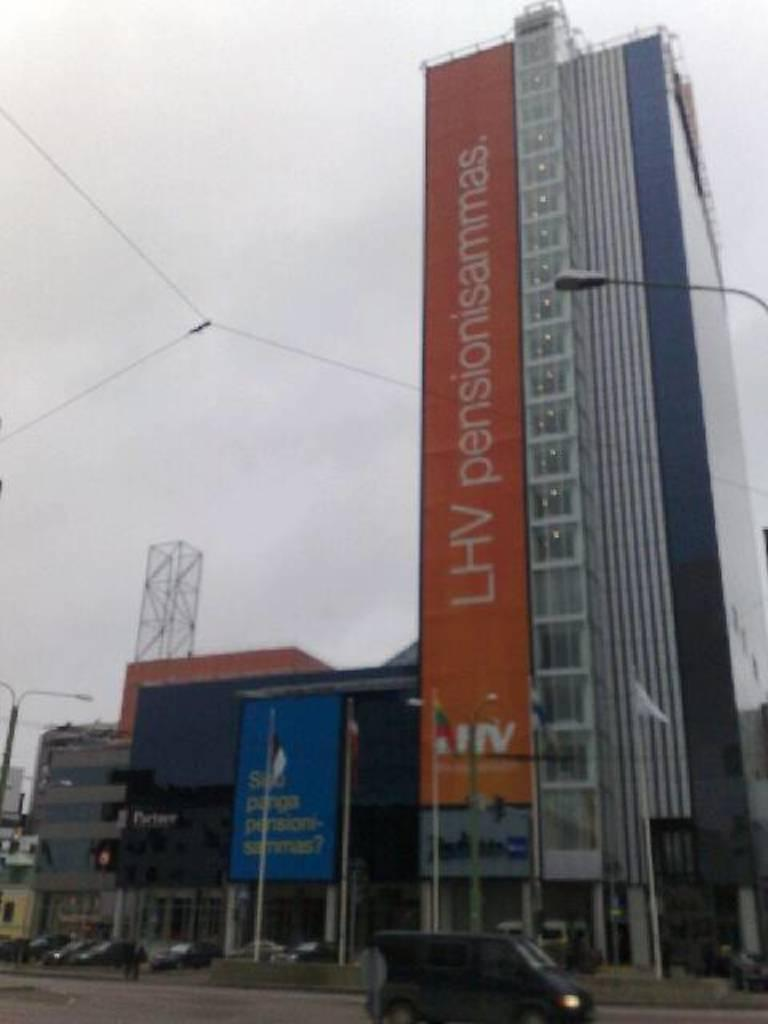What types of objects are present in the image? There are vehicles, a hoarding with text, flags, light poles, and buildings in the image. Can you describe the hoarding in the image? The hoarding in the image has text on it. What else can be seen in the image besides the hoarding? There are flags and light poles in the image. What is visible at the top of the image? The sky is visible at the top of the image. Are there any visible zippers on the vehicles in the image? There are no visible zippers on the vehicles in the image. Can you see the toes of the people in the image? There are no people visible in the image, so their toes cannot be seen. 